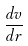Convert formula to latex. <formula><loc_0><loc_0><loc_500><loc_500>\frac { d v } { d r }</formula> 